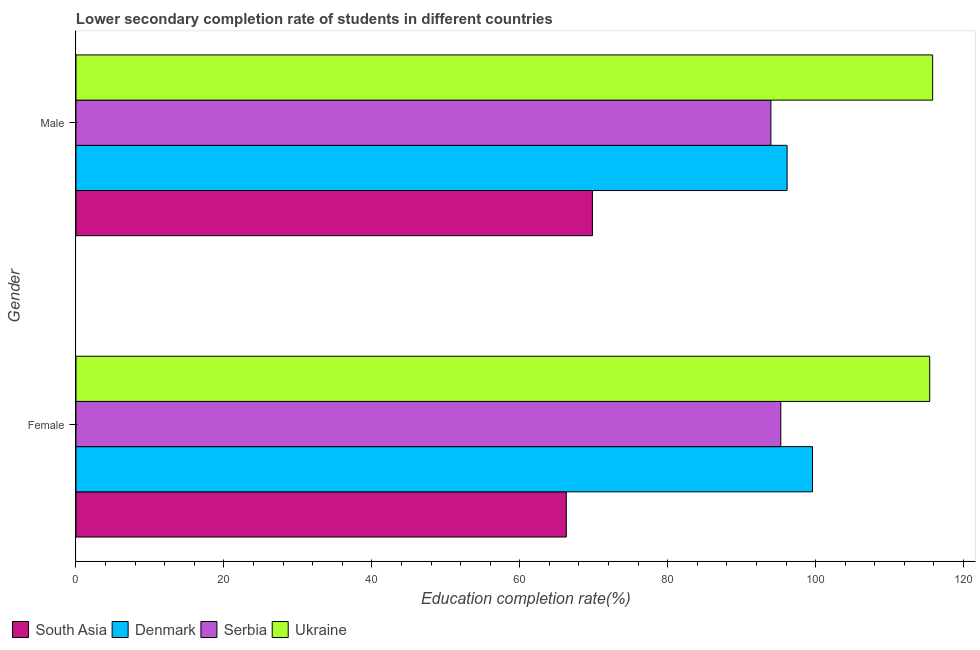How many groups of bars are there?
Give a very brief answer. 2. Are the number of bars per tick equal to the number of legend labels?
Provide a succinct answer. Yes. How many bars are there on the 2nd tick from the top?
Keep it short and to the point. 4. What is the label of the 1st group of bars from the top?
Give a very brief answer. Male. What is the education completion rate of male students in Serbia?
Offer a terse response. 93.95. Across all countries, what is the maximum education completion rate of male students?
Your answer should be compact. 115.82. Across all countries, what is the minimum education completion rate of male students?
Offer a terse response. 69.82. In which country was the education completion rate of female students maximum?
Your answer should be compact. Ukraine. What is the total education completion rate of female students in the graph?
Make the answer very short. 376.58. What is the difference between the education completion rate of female students in South Asia and that in Denmark?
Keep it short and to the point. -33.28. What is the difference between the education completion rate of male students in Serbia and the education completion rate of female students in Denmark?
Your answer should be very brief. -5.62. What is the average education completion rate of male students per country?
Give a very brief answer. 93.93. What is the difference between the education completion rate of male students and education completion rate of female students in South Asia?
Provide a succinct answer. 3.53. In how many countries, is the education completion rate of male students greater than 80 %?
Your response must be concise. 3. What is the ratio of the education completion rate of male students in South Asia to that in Denmark?
Keep it short and to the point. 0.73. What does the 3rd bar from the top in Female represents?
Your answer should be very brief. Denmark. What does the 1st bar from the bottom in Female represents?
Keep it short and to the point. South Asia. Are all the bars in the graph horizontal?
Keep it short and to the point. Yes. How are the legend labels stacked?
Offer a very short reply. Horizontal. What is the title of the graph?
Offer a very short reply. Lower secondary completion rate of students in different countries. Does "Northern Mariana Islands" appear as one of the legend labels in the graph?
Your answer should be compact. No. What is the label or title of the X-axis?
Your response must be concise. Education completion rate(%). What is the label or title of the Y-axis?
Offer a very short reply. Gender. What is the Education completion rate(%) of South Asia in Female?
Provide a short and direct response. 66.29. What is the Education completion rate(%) in Denmark in Female?
Give a very brief answer. 99.58. What is the Education completion rate(%) of Serbia in Female?
Offer a very short reply. 95.29. What is the Education completion rate(%) in Ukraine in Female?
Give a very brief answer. 115.42. What is the Education completion rate(%) of South Asia in Male?
Ensure brevity in your answer.  69.82. What is the Education completion rate(%) of Denmark in Male?
Provide a succinct answer. 96.14. What is the Education completion rate(%) of Serbia in Male?
Your answer should be compact. 93.95. What is the Education completion rate(%) in Ukraine in Male?
Provide a succinct answer. 115.82. Across all Gender, what is the maximum Education completion rate(%) of South Asia?
Offer a very short reply. 69.82. Across all Gender, what is the maximum Education completion rate(%) in Denmark?
Provide a succinct answer. 99.58. Across all Gender, what is the maximum Education completion rate(%) of Serbia?
Your answer should be compact. 95.29. Across all Gender, what is the maximum Education completion rate(%) of Ukraine?
Ensure brevity in your answer.  115.82. Across all Gender, what is the minimum Education completion rate(%) in South Asia?
Give a very brief answer. 66.29. Across all Gender, what is the minimum Education completion rate(%) in Denmark?
Keep it short and to the point. 96.14. Across all Gender, what is the minimum Education completion rate(%) of Serbia?
Keep it short and to the point. 93.95. Across all Gender, what is the minimum Education completion rate(%) of Ukraine?
Give a very brief answer. 115.42. What is the total Education completion rate(%) of South Asia in the graph?
Your answer should be very brief. 136.11. What is the total Education completion rate(%) in Denmark in the graph?
Offer a very short reply. 195.72. What is the total Education completion rate(%) in Serbia in the graph?
Ensure brevity in your answer.  189.24. What is the total Education completion rate(%) in Ukraine in the graph?
Your answer should be very brief. 231.24. What is the difference between the Education completion rate(%) of South Asia in Female and that in Male?
Provide a short and direct response. -3.53. What is the difference between the Education completion rate(%) in Denmark in Female and that in Male?
Your response must be concise. 3.43. What is the difference between the Education completion rate(%) in Serbia in Female and that in Male?
Provide a succinct answer. 1.34. What is the difference between the Education completion rate(%) of Ukraine in Female and that in Male?
Keep it short and to the point. -0.4. What is the difference between the Education completion rate(%) of South Asia in Female and the Education completion rate(%) of Denmark in Male?
Your response must be concise. -29.85. What is the difference between the Education completion rate(%) of South Asia in Female and the Education completion rate(%) of Serbia in Male?
Make the answer very short. -27.66. What is the difference between the Education completion rate(%) in South Asia in Female and the Education completion rate(%) in Ukraine in Male?
Offer a terse response. -49.53. What is the difference between the Education completion rate(%) in Denmark in Female and the Education completion rate(%) in Serbia in Male?
Your answer should be compact. 5.62. What is the difference between the Education completion rate(%) in Denmark in Female and the Education completion rate(%) in Ukraine in Male?
Keep it short and to the point. -16.25. What is the difference between the Education completion rate(%) of Serbia in Female and the Education completion rate(%) of Ukraine in Male?
Ensure brevity in your answer.  -20.53. What is the average Education completion rate(%) in South Asia per Gender?
Offer a very short reply. 68.06. What is the average Education completion rate(%) in Denmark per Gender?
Ensure brevity in your answer.  97.86. What is the average Education completion rate(%) of Serbia per Gender?
Give a very brief answer. 94.62. What is the average Education completion rate(%) of Ukraine per Gender?
Your answer should be compact. 115.62. What is the difference between the Education completion rate(%) in South Asia and Education completion rate(%) in Denmark in Female?
Your response must be concise. -33.28. What is the difference between the Education completion rate(%) in South Asia and Education completion rate(%) in Serbia in Female?
Offer a very short reply. -28.99. What is the difference between the Education completion rate(%) in South Asia and Education completion rate(%) in Ukraine in Female?
Offer a terse response. -49.13. What is the difference between the Education completion rate(%) of Denmark and Education completion rate(%) of Serbia in Female?
Your answer should be very brief. 4.29. What is the difference between the Education completion rate(%) of Denmark and Education completion rate(%) of Ukraine in Female?
Your answer should be compact. -15.85. What is the difference between the Education completion rate(%) in Serbia and Education completion rate(%) in Ukraine in Female?
Offer a very short reply. -20.13. What is the difference between the Education completion rate(%) in South Asia and Education completion rate(%) in Denmark in Male?
Your response must be concise. -26.32. What is the difference between the Education completion rate(%) of South Asia and Education completion rate(%) of Serbia in Male?
Provide a succinct answer. -24.13. What is the difference between the Education completion rate(%) of South Asia and Education completion rate(%) of Ukraine in Male?
Provide a short and direct response. -46. What is the difference between the Education completion rate(%) of Denmark and Education completion rate(%) of Serbia in Male?
Your answer should be very brief. 2.19. What is the difference between the Education completion rate(%) of Denmark and Education completion rate(%) of Ukraine in Male?
Your answer should be compact. -19.68. What is the difference between the Education completion rate(%) of Serbia and Education completion rate(%) of Ukraine in Male?
Keep it short and to the point. -21.87. What is the ratio of the Education completion rate(%) in South Asia in Female to that in Male?
Offer a very short reply. 0.95. What is the ratio of the Education completion rate(%) in Denmark in Female to that in Male?
Provide a succinct answer. 1.04. What is the ratio of the Education completion rate(%) of Serbia in Female to that in Male?
Provide a succinct answer. 1.01. What is the difference between the highest and the second highest Education completion rate(%) of South Asia?
Your answer should be very brief. 3.53. What is the difference between the highest and the second highest Education completion rate(%) in Denmark?
Your answer should be compact. 3.43. What is the difference between the highest and the second highest Education completion rate(%) of Serbia?
Give a very brief answer. 1.34. What is the difference between the highest and the second highest Education completion rate(%) of Ukraine?
Ensure brevity in your answer.  0.4. What is the difference between the highest and the lowest Education completion rate(%) in South Asia?
Offer a terse response. 3.53. What is the difference between the highest and the lowest Education completion rate(%) in Denmark?
Ensure brevity in your answer.  3.43. What is the difference between the highest and the lowest Education completion rate(%) in Serbia?
Ensure brevity in your answer.  1.34. What is the difference between the highest and the lowest Education completion rate(%) of Ukraine?
Your response must be concise. 0.4. 